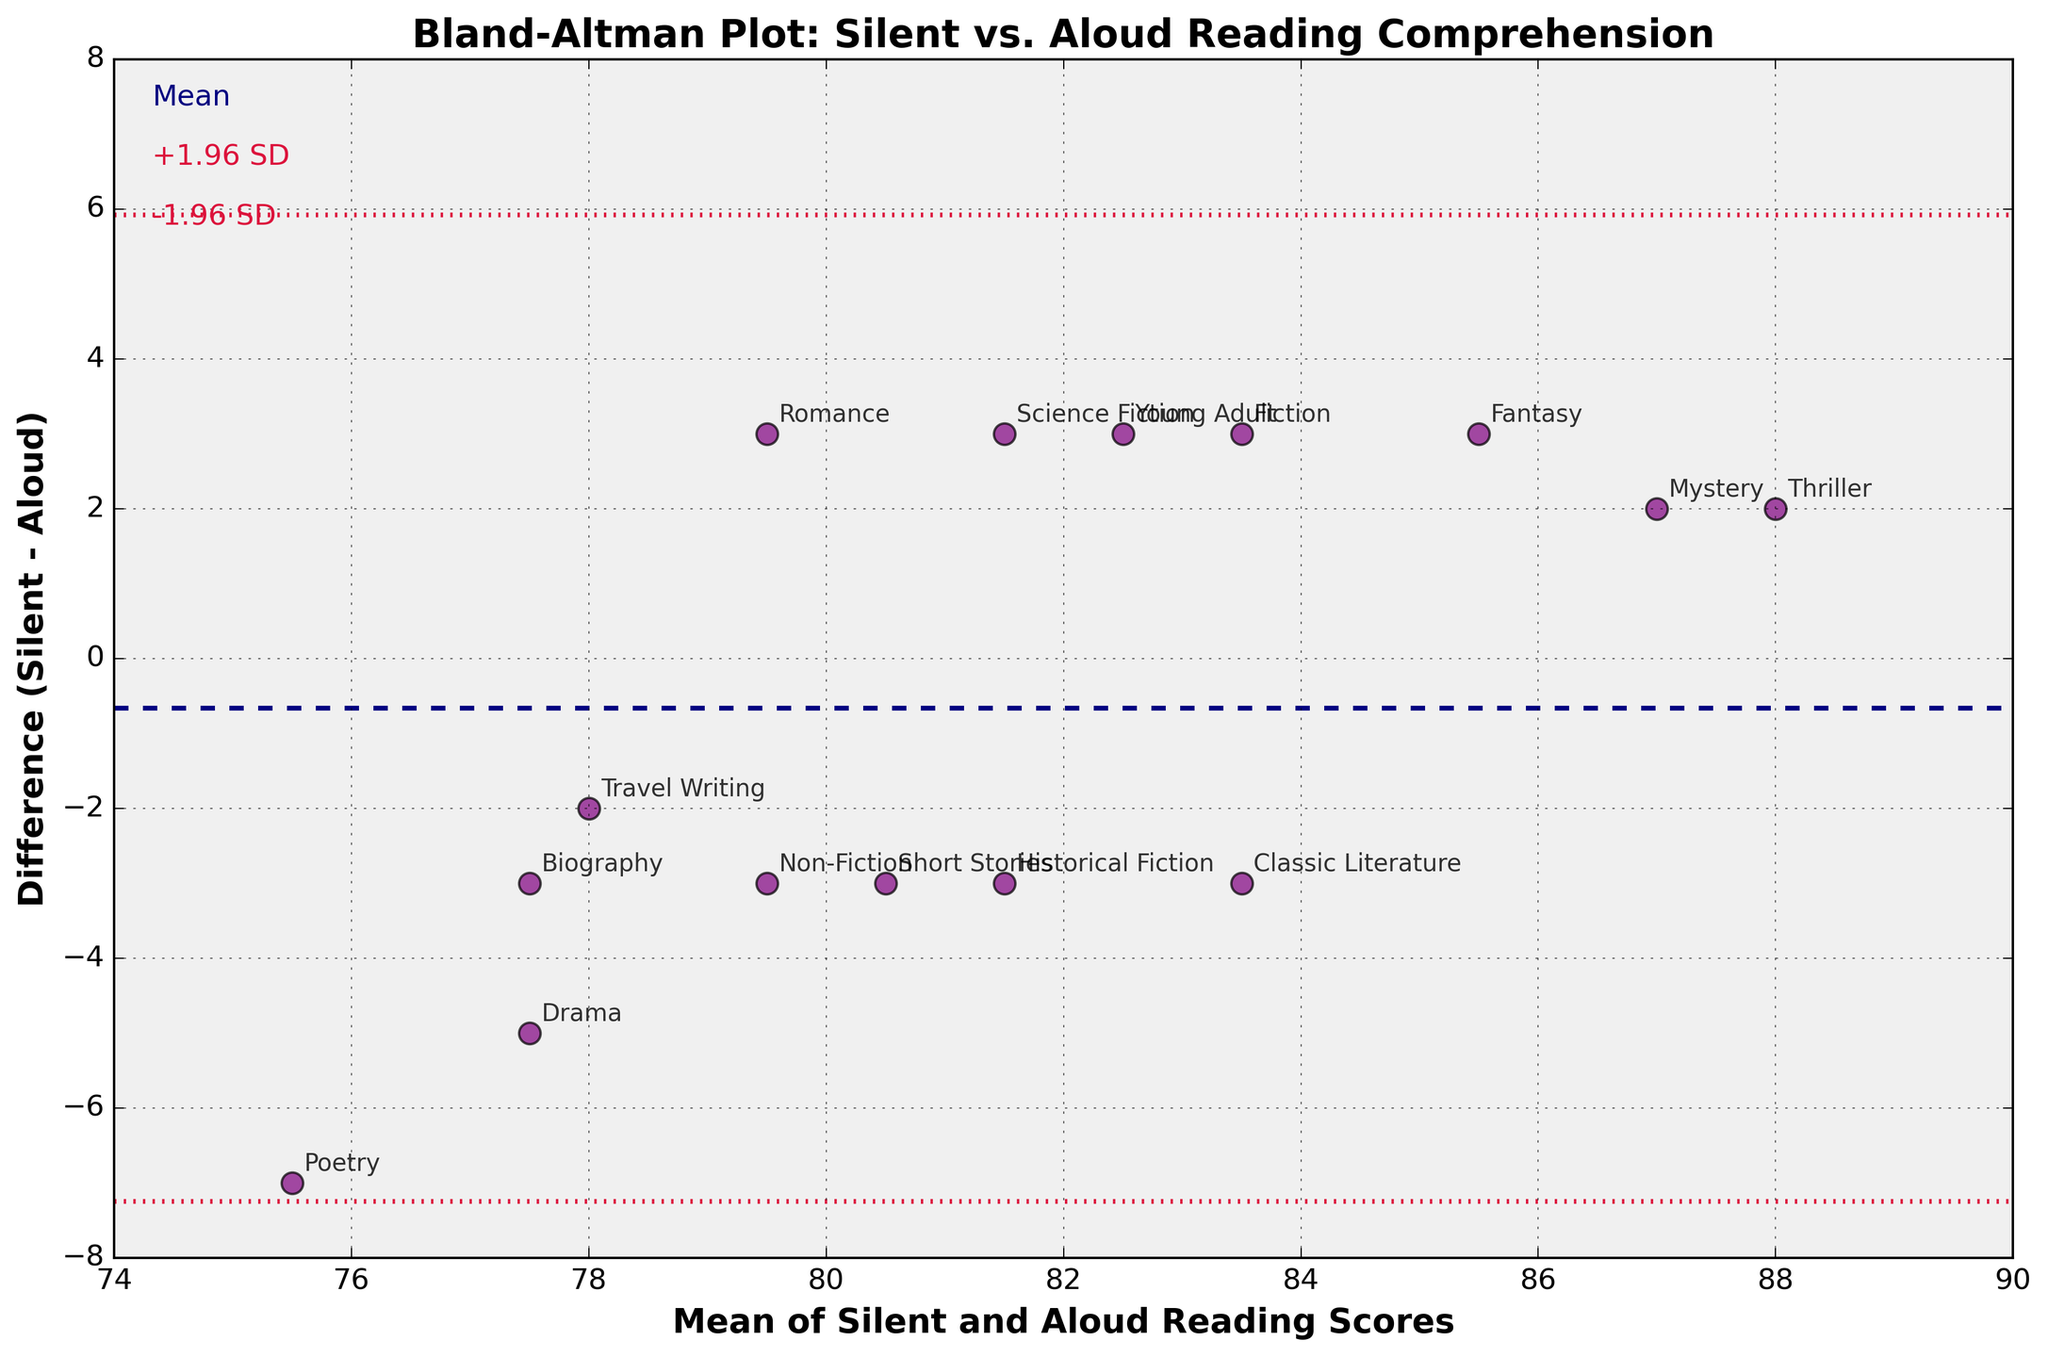What is the title of the plot? The title is usually found at the top of the plot. It provides a summary of what the plot represents. Here, the title reads "Bland-Altman Plot: Silent vs. Aloud Reading Comprehension".
Answer: Bland-Altman Plot: Silent vs. Aloud Reading Comprehension What do the x and y axes represent? The x-axis label is "Mean of Silent and Aloud Reading Scores," and the y-axis label is "Difference (Silent - Aloud)." These labels state what the axes represent. The x-axis shows the average of the silent and aloud scores, and the y-axis shows the difference between them.
Answer: Mean of Silent and Aloud Reading Scores (x-axis), Difference (Silent - Aloud) (y-axis) How many data points are there in the plot? Count the number of data points plotted, which corresponds to the number of genres. Each genre represents one data point in the plot. By observing, there are 15 genres, so there should be 15 data points.
Answer: 15 Which genre has the largest positive difference between silent and aloud scores? Find the point on the plot that has the highest y-value (difference between Silent and Aloud). The annotated text at this point will indicate the genre. Here, "Poetry" is the highest point.
Answer: Poetry Are there any genres where the silent reading score is lower than the reading aloud score? Points below the y=0 line indicate genres where the silent reading score is lower than the reading aloud score. Annotate these points to find the genres. "Non-Fiction" and "Historical Fiction" are below this line.
Answer: Non-Fiction, Historical Fiction What is the mean difference in scores between silent and aloud reading? The mean difference is shown as a dashed horizontal line on the plot. The text annotation "Mean" often indicates this line. Here, the mean difference is approximately 0.7333.
Answer: 0.7333 What is the standard deviation of the differences in scores? Although not explicitly shown in a numeric format, the distance between the mean line and the +1.96 SD or -1.96 SD lines can be used to infer it. These lines are typically annotated. Here, the standard deviation is approximately 3.4 (calculated as (upper limit - mean)/1.96).
Answer: 3.4 Which genre has the closest score between silent and aloud reading? The closest score will be at the point where the difference (y-value) is closest to zero. Here, "Thriller" and "Mystery" have almost zero difference.
Answer: Thriller, Mystery How does the variance of differences change as the mean score increases? Observe the spread of the points as you move along the x-axis (mean score). The variance appears to remain relatively constant as the spread does not significantly increase or decrease with higher mean scores.
Answer: Relatively constant What genre has the highest mean score? To find the genre with the highest mean score, look for the point furthest to the right on the x-axis. The annotation for this point will indicate the genre. Here, "Thriller" has the highest mean score.
Answer: Thriller 